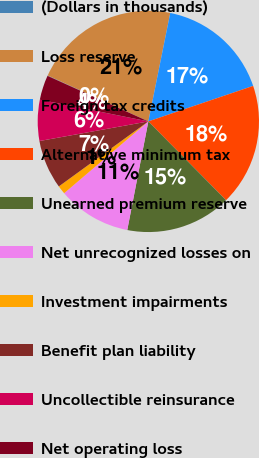Convert chart to OTSL. <chart><loc_0><loc_0><loc_500><loc_500><pie_chart><fcel>(Dollars in thousands)<fcel>Loss reserve<fcel>Foreign tax credits<fcel>Alternative minimum tax<fcel>Unearned premium reserve<fcel>Net unrecognized losses on<fcel>Investment impairments<fcel>Benefit plan liability<fcel>Uncollectible reinsurance<fcel>Net operating loss<nl><fcel>0.06%<fcel>21.36%<fcel>16.63%<fcel>17.81%<fcel>15.44%<fcel>10.71%<fcel>1.24%<fcel>7.16%<fcel>5.98%<fcel>3.61%<nl></chart> 